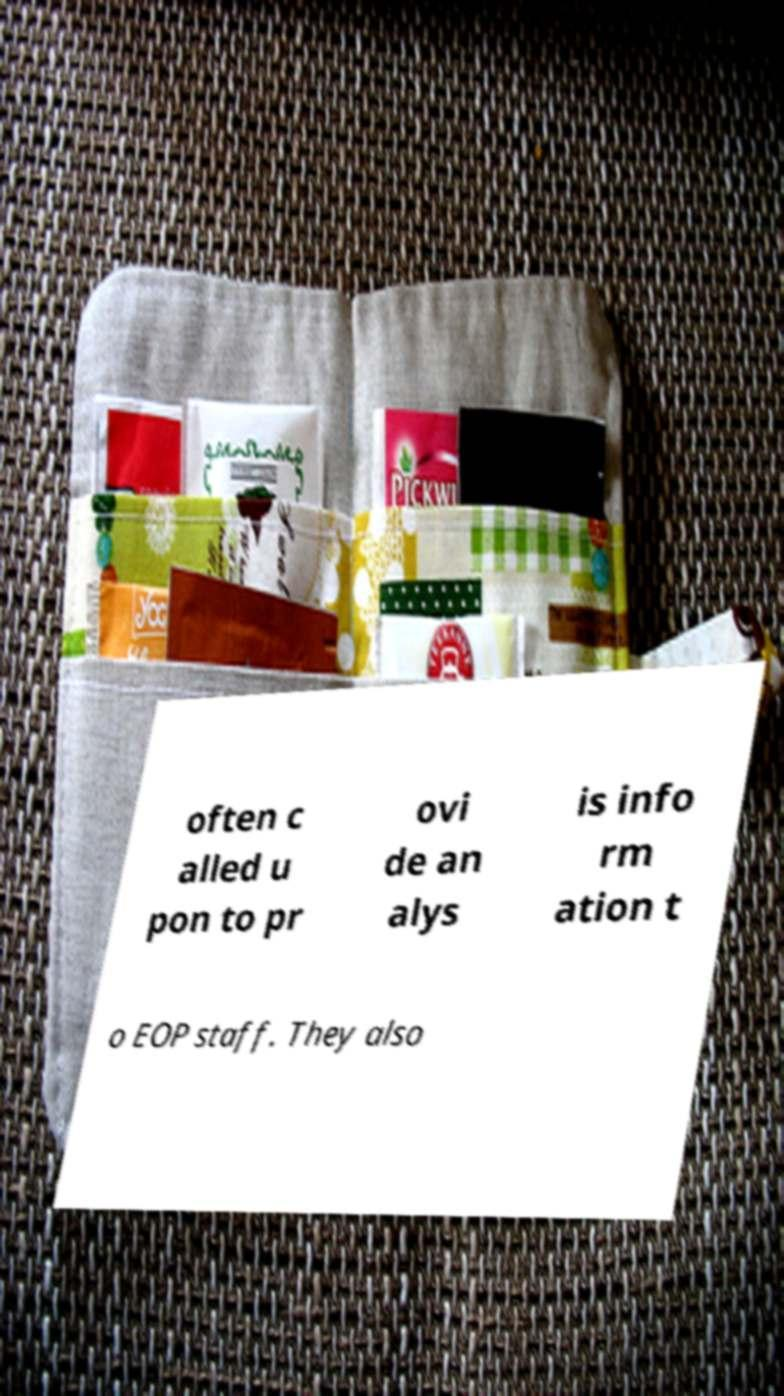Please read and relay the text visible in this image. What does it say? often c alled u pon to pr ovi de an alys is info rm ation t o EOP staff. They also 